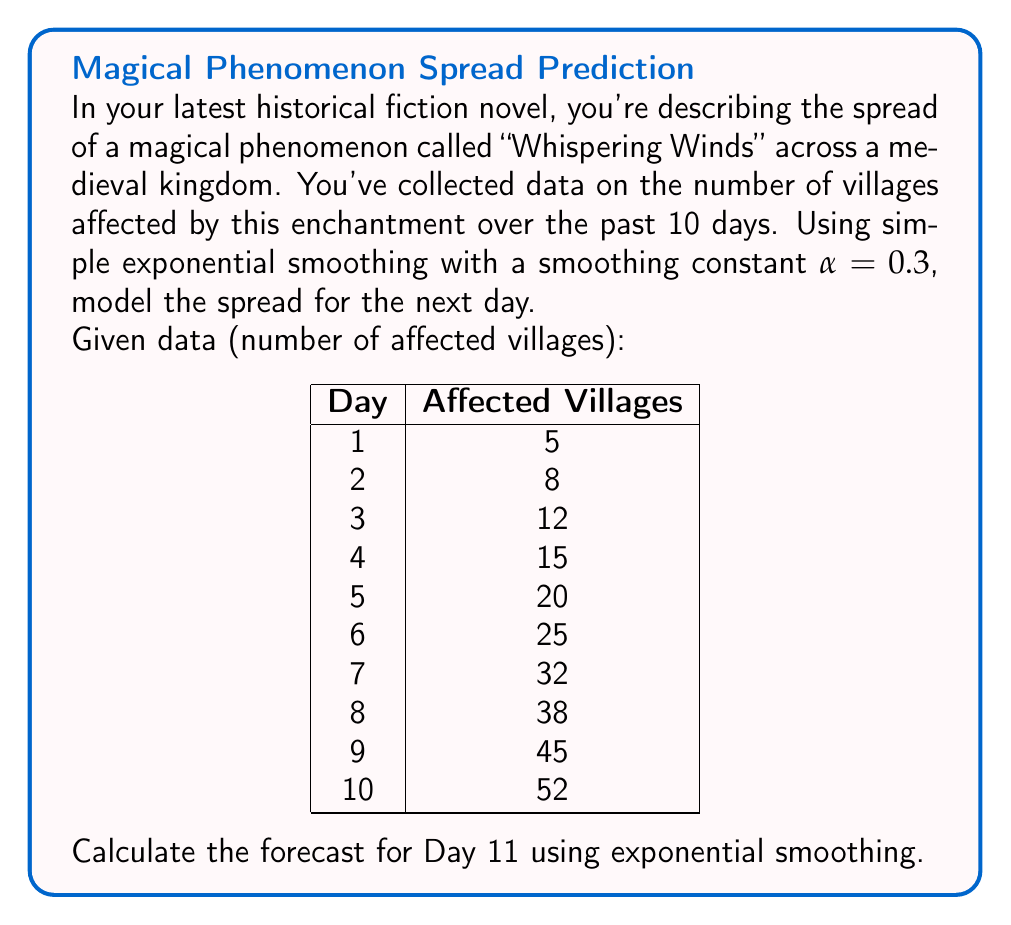Provide a solution to this math problem. To solve this problem, we'll use the simple exponential smoothing formula:

$$F_{t+1} = \alpha Y_t + (1-\alpha)F_t$$

Where:
$F_{t+1}$ is the forecast for the next period
$\alpha$ is the smoothing constant (0.3 in this case)
$Y_t$ is the actual value at time t
$F_t$ is the forecast for the current period

Let's calculate step by step:

1) For the first forecast (Day 2), we'll use the actual value of Day 1 as our initial forecast:
   $F_2 = 5$

2) Now, let's calculate each forecast:

   Day 3: $F_3 = 0.3(8) + 0.7(5) = 5.9$
   Day 4: $F_4 = 0.3(12) + 0.7(5.9) = 7.73$
   Day 5: $F_5 = 0.3(15) + 0.7(7.73) = 9.911$
   Day 6: $F_6 = 0.3(20) + 0.7(9.911) = 12.9377$
   Day 7: $F_7 = 0.3(25) + 0.7(12.9377) = 16.55639$
   Day 8: $F_8 = 0.3(32) + 0.7(16.55639) = 21.189473$
   Day 9: $F_9 = 0.3(38) + 0.7(21.189473) = 26.4326311$
   Day 10: $F_{10} = 0.3(45) + 0.7(26.4326311) = 32.1028418$

3) Finally, for Day 11:
   $F_{11} = 0.3(52) + 0.7(32.1028418) = 38.2719893$

Thus, the forecast for Day 11 is approximately 38.27 villages.
Answer: 38.27 villages 